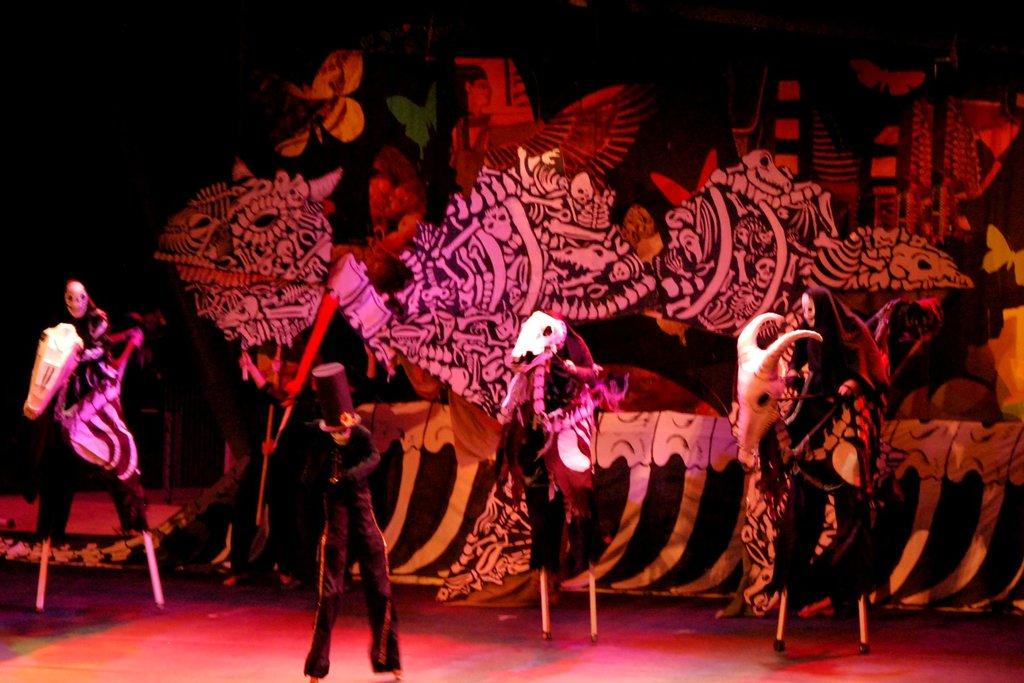What is the main subject of the image? There is a person standing in the image. What other objects or features can be seen in the image? There are statues and paintings in the image. What type of card is being used by the person in the image? There is no card present in the image; the person is standing near statues and paintings. 